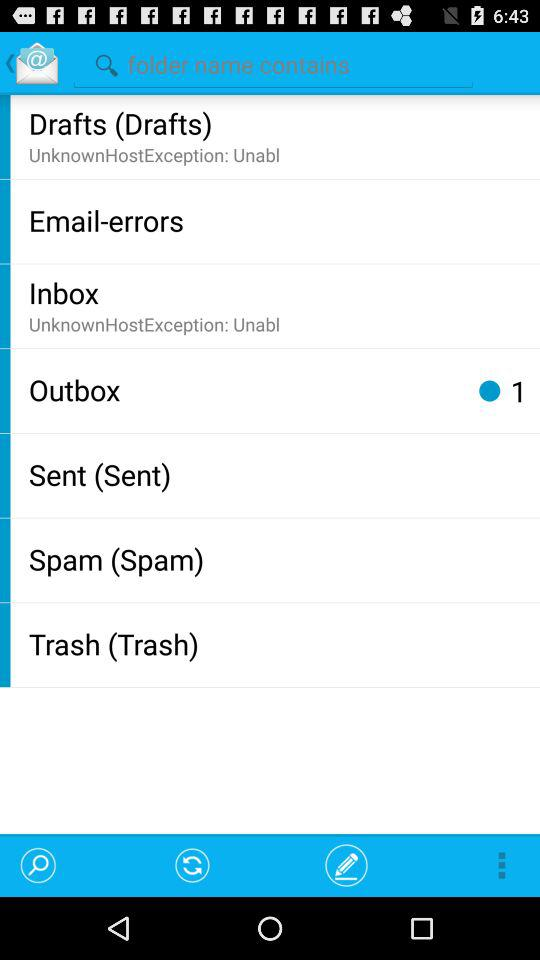How many emails are present in the outbox? There is 1 email present in the outbox. 